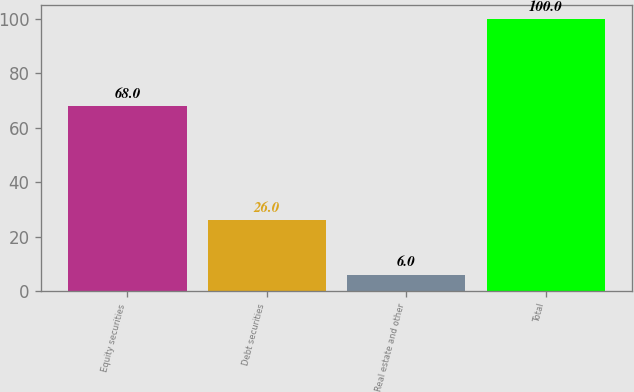Convert chart to OTSL. <chart><loc_0><loc_0><loc_500><loc_500><bar_chart><fcel>Equity securities<fcel>Debt securities<fcel>Real estate and other<fcel>Total<nl><fcel>68<fcel>26<fcel>6<fcel>100<nl></chart> 